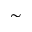Convert formula to latex. <formula><loc_0><loc_0><loc_500><loc_500>\sim</formula> 